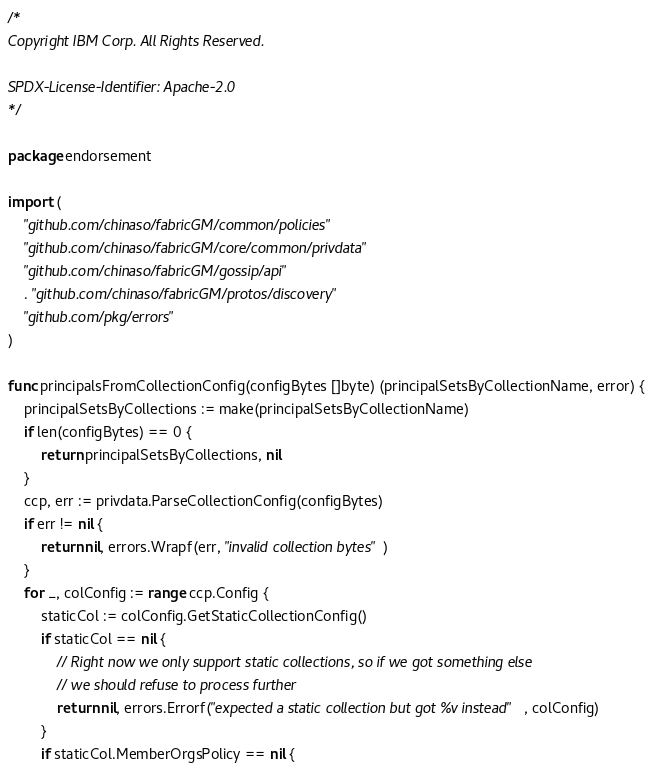Convert code to text. <code><loc_0><loc_0><loc_500><loc_500><_Go_>/*
Copyright IBM Corp. All Rights Reserved.

SPDX-License-Identifier: Apache-2.0
*/

package endorsement

import (
	"github.com/chinaso/fabricGM/common/policies"
	"github.com/chinaso/fabricGM/core/common/privdata"
	"github.com/chinaso/fabricGM/gossip/api"
	. "github.com/chinaso/fabricGM/protos/discovery"
	"github.com/pkg/errors"
)

func principalsFromCollectionConfig(configBytes []byte) (principalSetsByCollectionName, error) {
	principalSetsByCollections := make(principalSetsByCollectionName)
	if len(configBytes) == 0 {
		return principalSetsByCollections, nil
	}
	ccp, err := privdata.ParseCollectionConfig(configBytes)
	if err != nil {
		return nil, errors.Wrapf(err, "invalid collection bytes")
	}
	for _, colConfig := range ccp.Config {
		staticCol := colConfig.GetStaticCollectionConfig()
		if staticCol == nil {
			// Right now we only support static collections, so if we got something else
			// we should refuse to process further
			return nil, errors.Errorf("expected a static collection but got %v instead", colConfig)
		}
		if staticCol.MemberOrgsPolicy == nil {</code> 